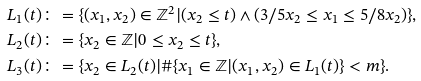Convert formula to latex. <formula><loc_0><loc_0><loc_500><loc_500>L _ { 1 } ( t ) & \colon = \{ ( x _ { 1 } , x _ { 2 } ) \in \mathbb { Z } ^ { 2 } | ( x _ { 2 } \leq t ) \wedge ( 3 / 5 x _ { 2 } \leq x _ { 1 } \leq 5 / 8 x _ { 2 } ) \} , \\ L _ { 2 } ( t ) & \colon = \{ x _ { 2 } \in \mathbb { Z } | 0 \leq x _ { 2 } \leq t \} , \\ L _ { 3 } ( t ) & \colon = \{ x _ { 2 } \in L _ { 2 } ( t ) | \# \{ x _ { 1 } \in \mathbb { Z } | ( x _ { 1 } , x _ { 2 } ) \in L _ { 1 } ( t ) \} < m \} .</formula> 